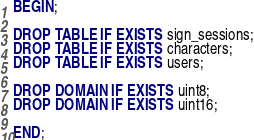<code> <loc_0><loc_0><loc_500><loc_500><_SQL_>BEGIN;

DROP TABLE IF EXISTS sign_sessions;
DROP TABLE IF EXISTS characters;
DROP TABLE IF EXISTS users;

DROP DOMAIN IF EXISTS uint8;
DROP DOMAIN IF EXISTS uint16;

END;</code> 